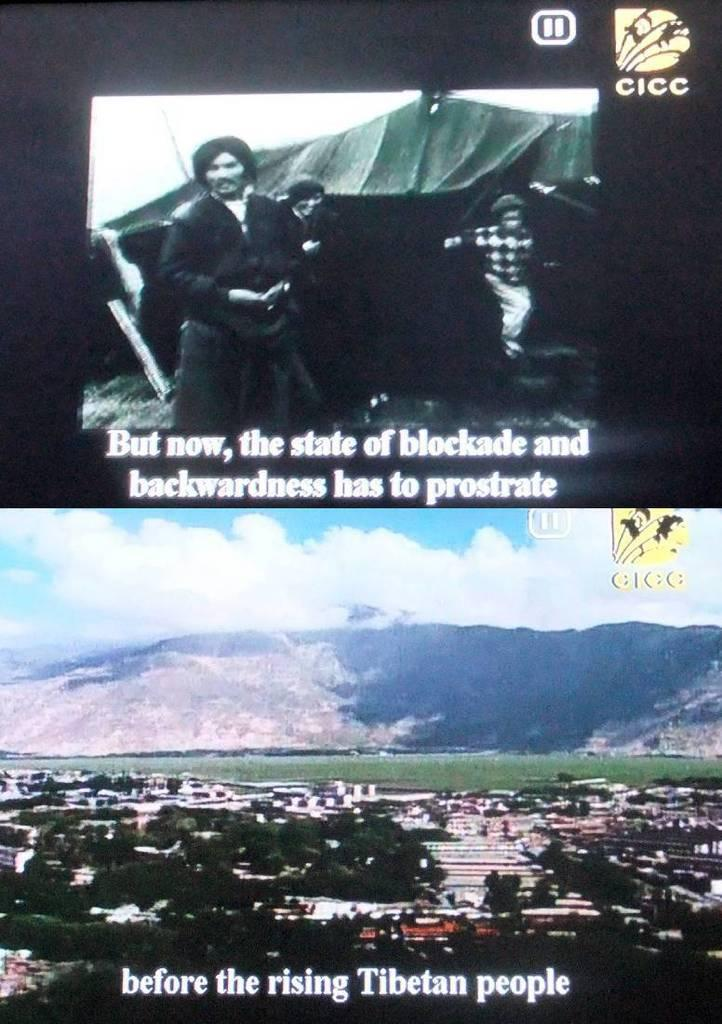<image>
Relay a brief, clear account of the picture shown. The second screen says before the rising Tibetan people. 